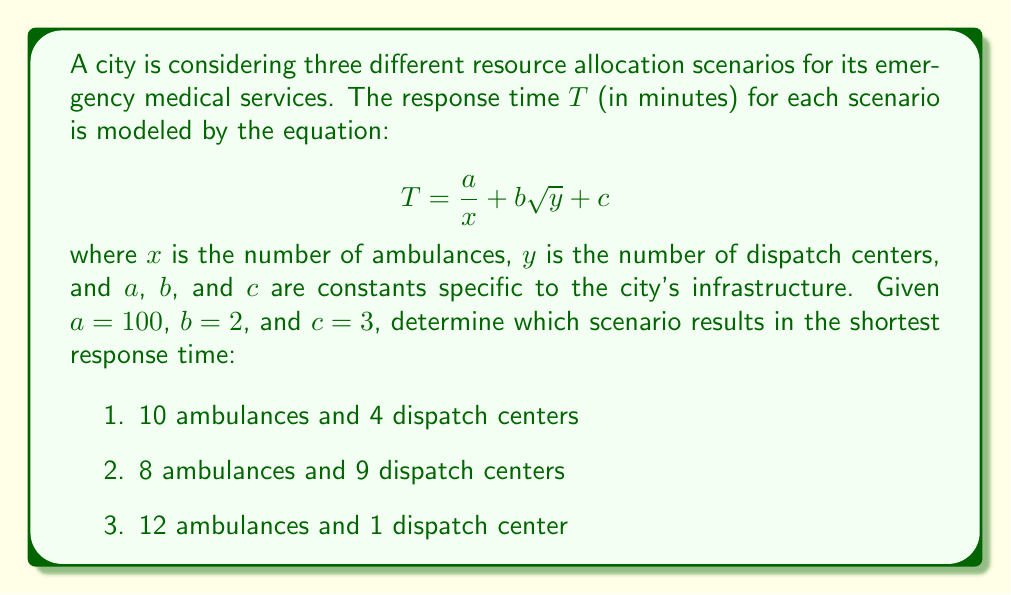Can you answer this question? To solve this problem, we need to calculate the response time for each scenario using the given equation and compare the results. Let's go through each scenario step-by-step:

1. For 10 ambulances and 4 dispatch centers:
   $$T_1 = \frac{100}{10} + 2\sqrt{4} + 3$$
   $$T_1 = 10 + 2(2) + 3$$
   $$T_1 = 10 + 4 + 3 = 17 \text{ minutes}$$

2. For 8 ambulances and 9 dispatch centers:
   $$T_2 = \frac{100}{8} + 2\sqrt{9} + 3$$
   $$T_2 = 12.5 + 2(3) + 3$$
   $$T_2 = 12.5 + 6 + 3 = 21.5 \text{ minutes}$$

3. For 12 ambulances and 1 dispatch center:
   $$T_3 = \frac{100}{12} + 2\sqrt{1} + 3$$
   $$T_3 = 8.33 + 2(1) + 3$$
   $$T_3 = 8.33 + 2 + 3 = 13.33 \text{ minutes}$$

Comparing the three results:
$T_3 < T_1 < T_2$

Therefore, the scenario with the shortest response time is scenario 3, with 12 ambulances and 1 dispatch center.
Answer: Scenario 3: 12 ambulances and 1 dispatch center (13.33 minutes) 